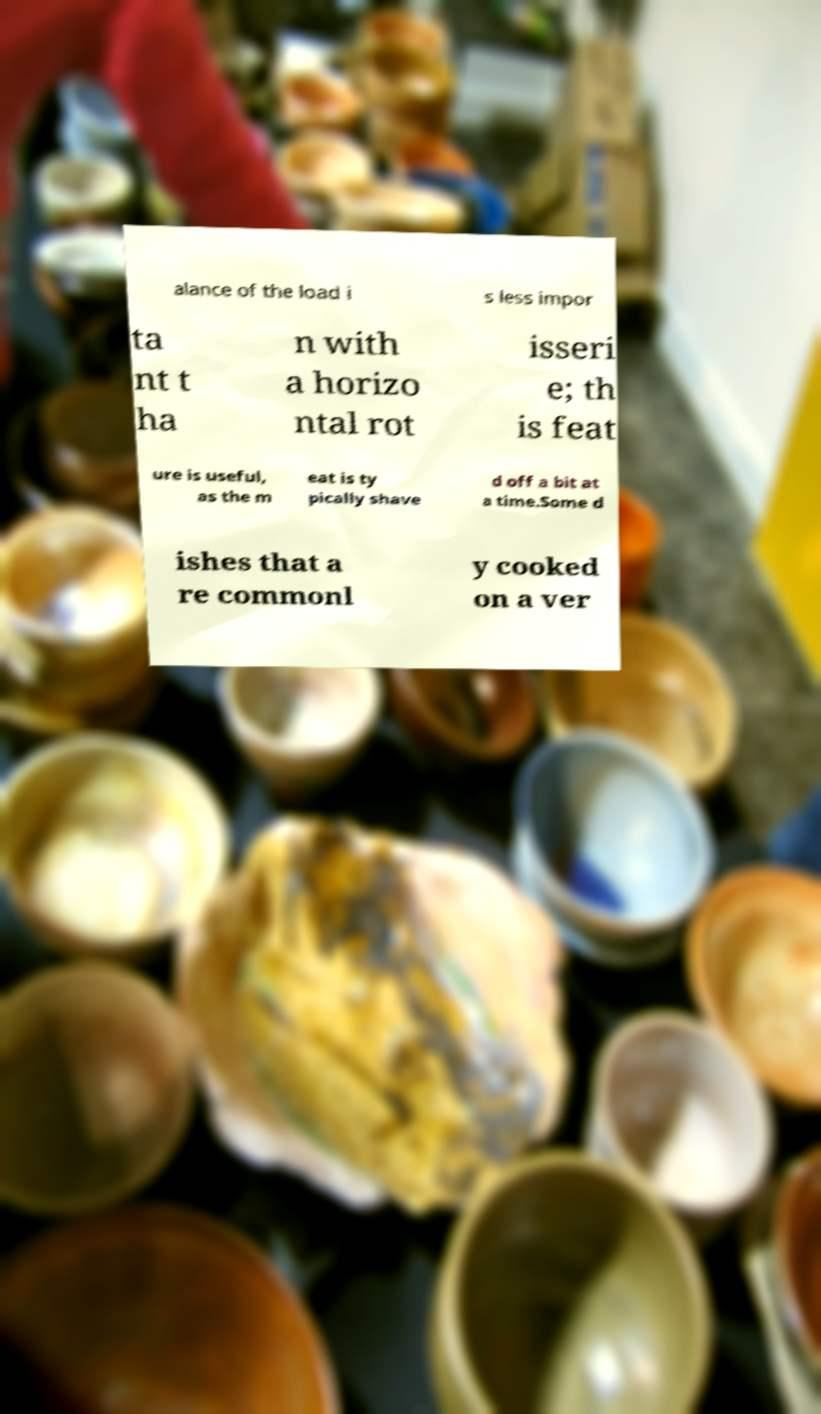I need the written content from this picture converted into text. Can you do that? alance of the load i s less impor ta nt t ha n with a horizo ntal rot isseri e; th is feat ure is useful, as the m eat is ty pically shave d off a bit at a time.Some d ishes that a re commonl y cooked on a ver 